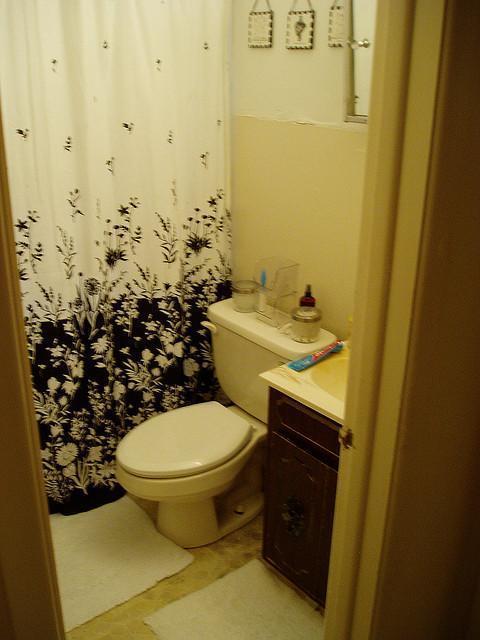How many rugs are there?
Give a very brief answer. 2. 